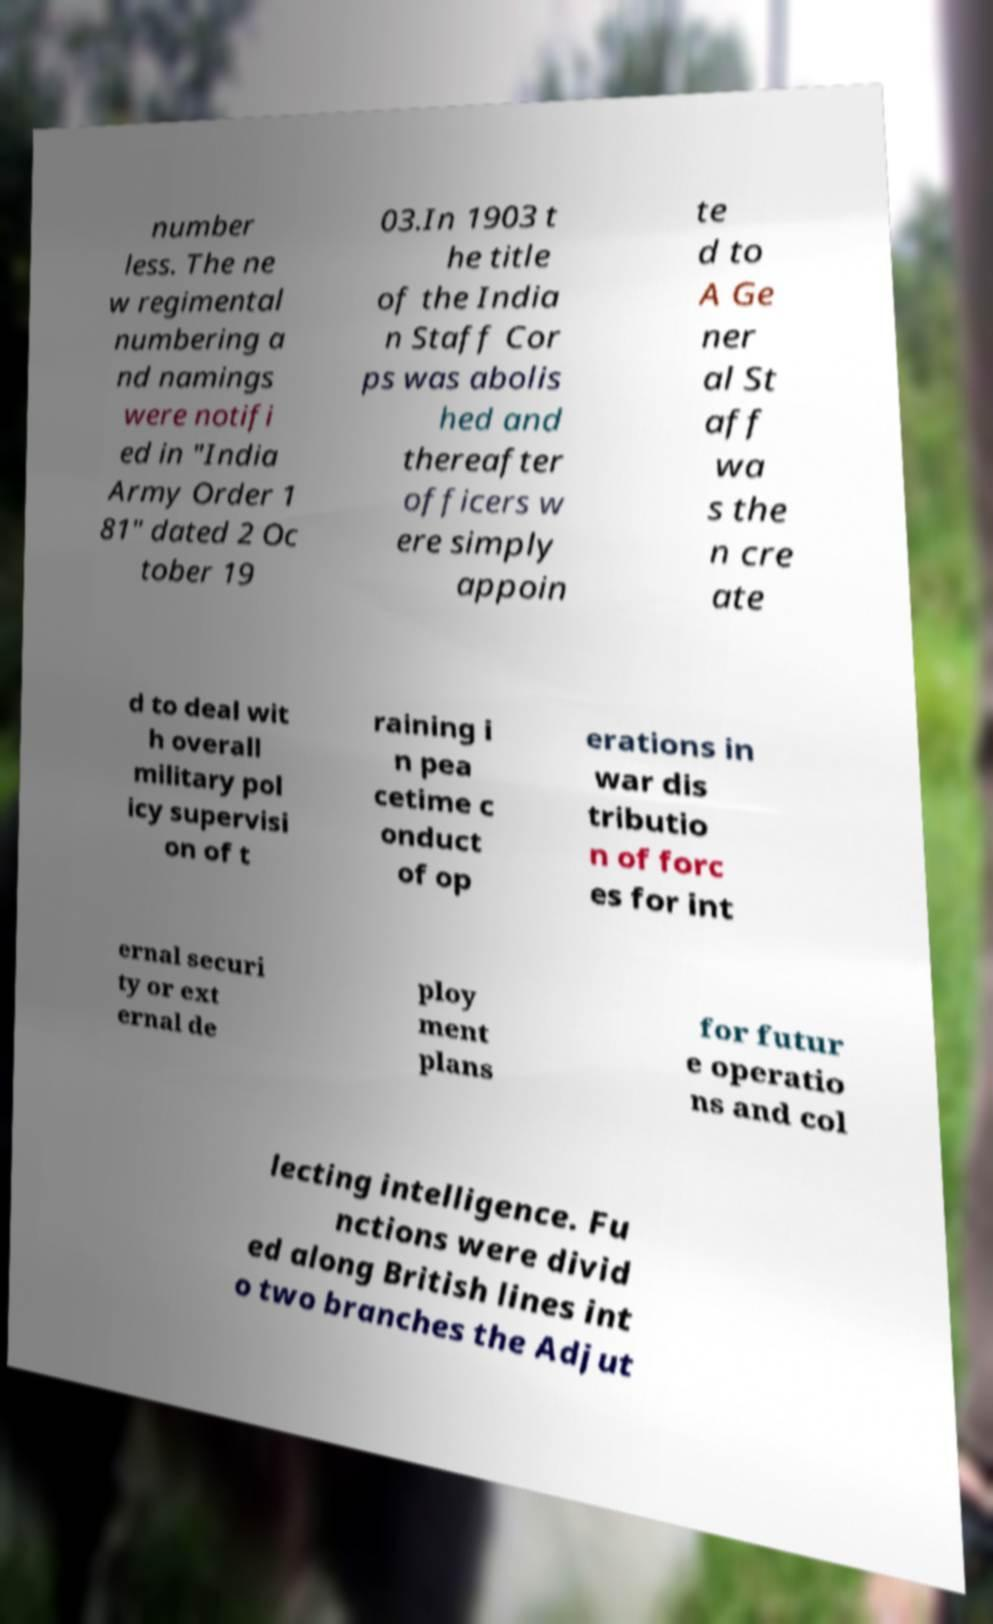Could you extract and type out the text from this image? number less. The ne w regimental numbering a nd namings were notifi ed in "India Army Order 1 81" dated 2 Oc tober 19 03.In 1903 t he title of the India n Staff Cor ps was abolis hed and thereafter officers w ere simply appoin te d to A Ge ner al St aff wa s the n cre ate d to deal wit h overall military pol icy supervisi on of t raining i n pea cetime c onduct of op erations in war dis tributio n of forc es for int ernal securi ty or ext ernal de ploy ment plans for futur e operatio ns and col lecting intelligence. Fu nctions were divid ed along British lines int o two branches the Adjut 